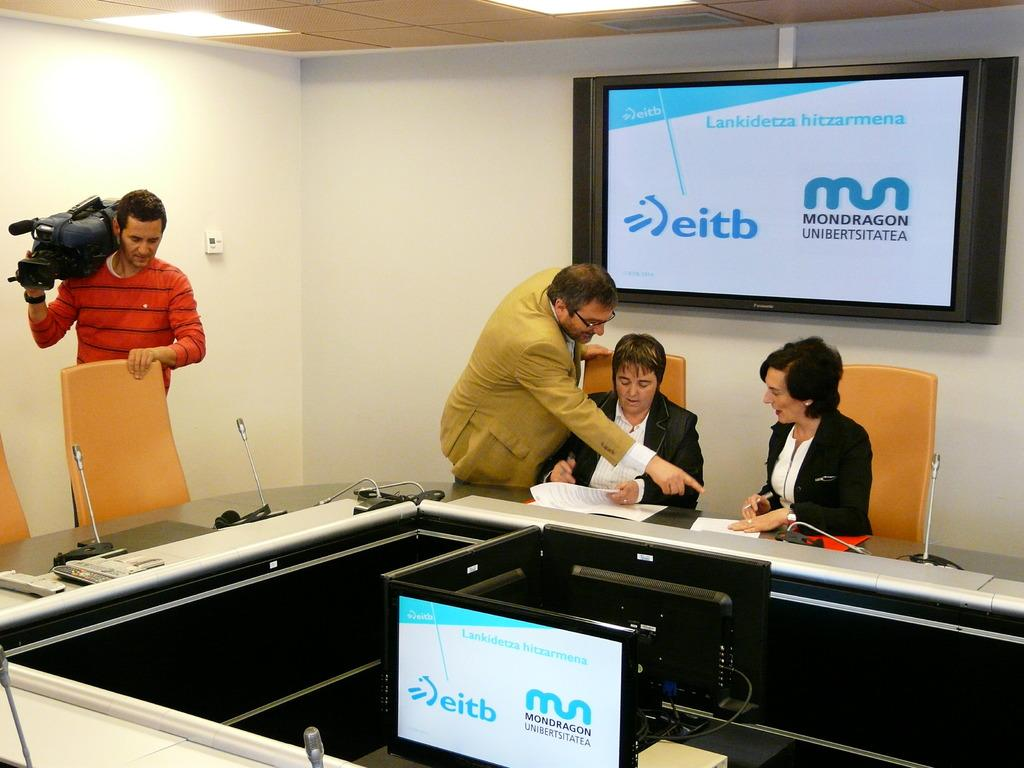<image>
Summarize the visual content of the image. A man is pointing at a sheet of paper that two woman are looking at under a TV that says Mondragon. 